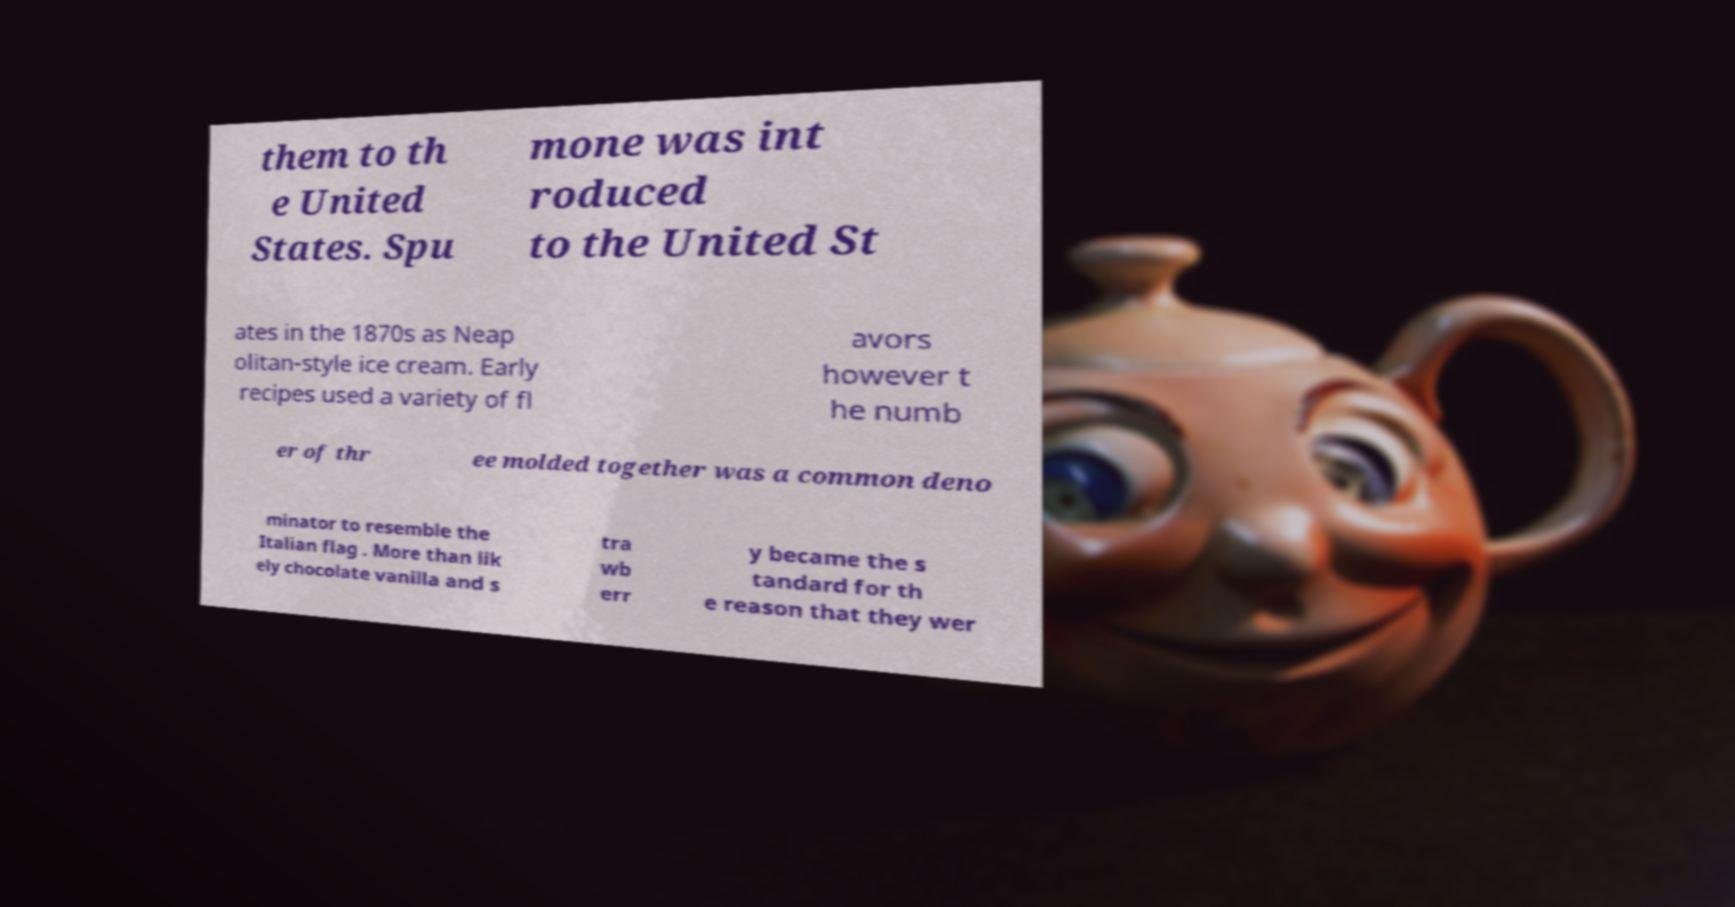Could you extract and type out the text from this image? them to th e United States. Spu mone was int roduced to the United St ates in the 1870s as Neap olitan-style ice cream. Early recipes used a variety of fl avors however t he numb er of thr ee molded together was a common deno minator to resemble the Italian flag . More than lik ely chocolate vanilla and s tra wb err y became the s tandard for th e reason that they wer 